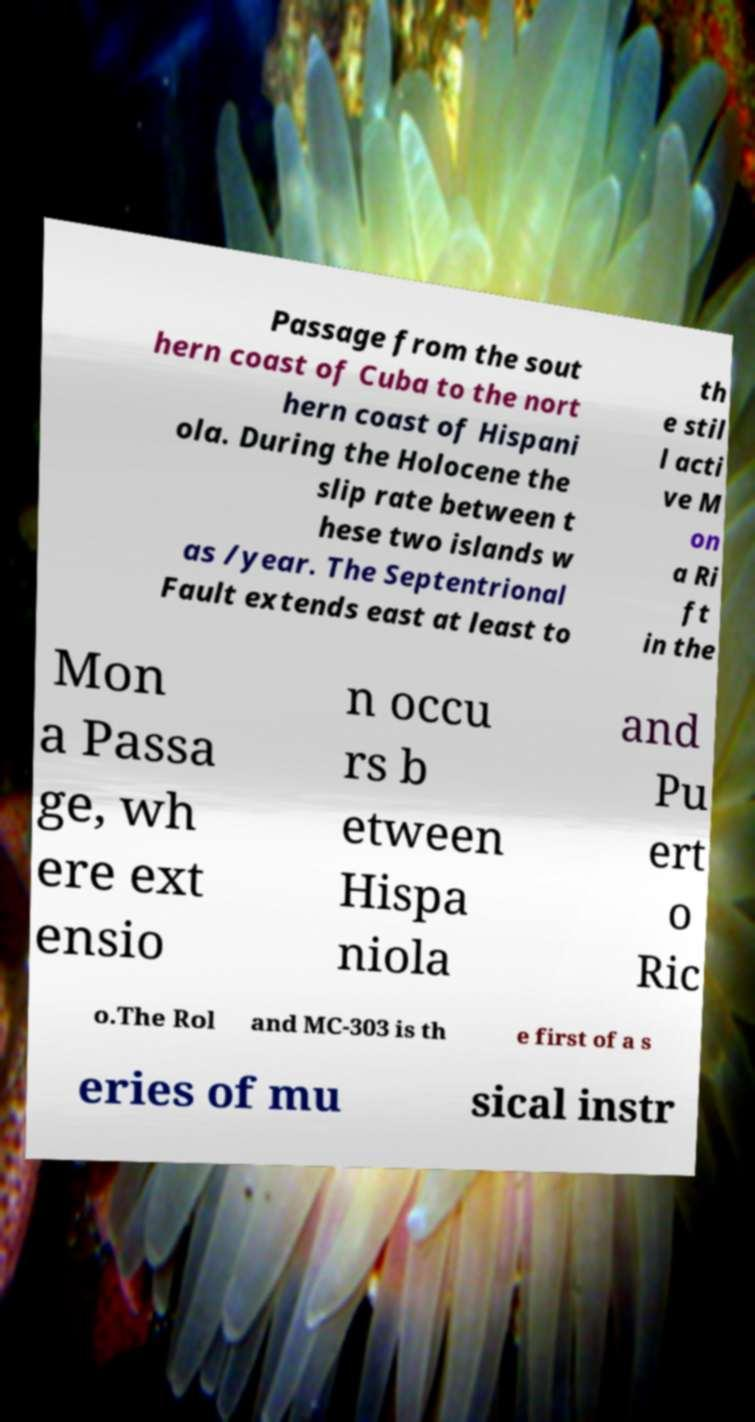Can you read and provide the text displayed in the image?This photo seems to have some interesting text. Can you extract and type it out for me? Passage from the sout hern coast of Cuba to the nort hern coast of Hispani ola. During the Holocene the slip rate between t hese two islands w as /year. The Septentrional Fault extends east at least to th e stil l acti ve M on a Ri ft in the Mon a Passa ge, wh ere ext ensio n occu rs b etween Hispa niola and Pu ert o Ric o.The Rol and MC-303 is th e first of a s eries of mu sical instr 